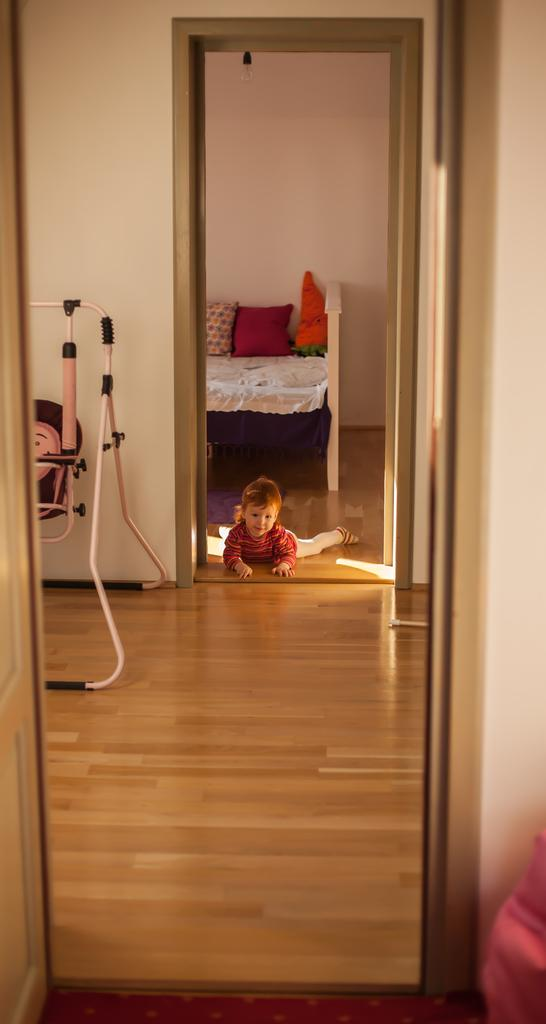What is the main subject in the room? There is a baby in the room. What is the baby's position in the room? The baby is lying on the floor. Where is the bed located in the room? The bed is on the left side of the image. What can be found on the bed? There are pillows on the bed. Can you see the baby touching the sidewalk in the image? There is no sidewalk present in the image, and the baby is lying on the floor, not touching a sidewalk. 